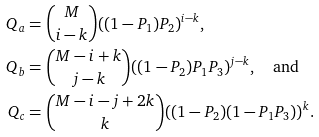Convert formula to latex. <formula><loc_0><loc_0><loc_500><loc_500>Q _ { a } & = { M \choose i - k } ( ( 1 - P _ { 1 } ) P _ { 2 } ) ^ { i - k } , \\ Q _ { b } & = { M - i + k \choose j - k } ( ( 1 - P _ { 2 } ) P _ { 1 } P _ { 3 } ) ^ { j - k } , \quad \text {and} \\ Q _ { c } & = { M - i - j + 2 k \choose k } ( ( 1 - P _ { 2 } ) ( 1 - P _ { 1 } P _ { 3 } ) ) ^ { k } .</formula> 